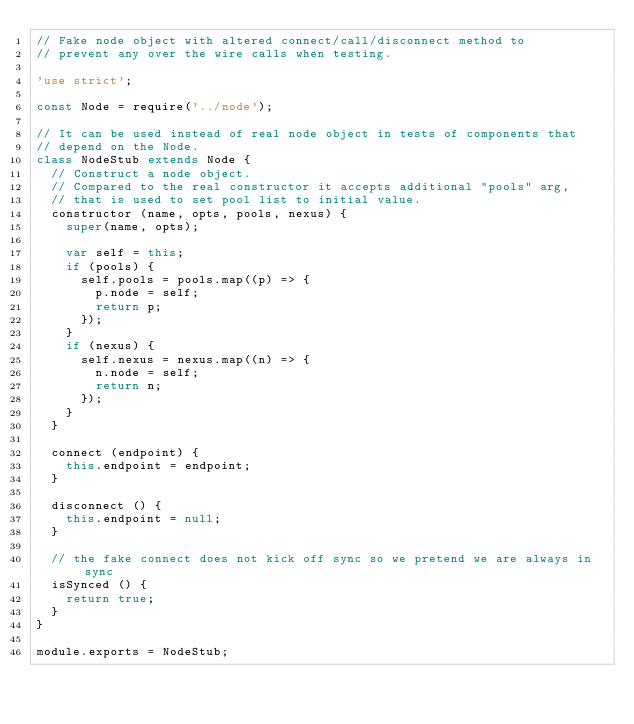Convert code to text. <code><loc_0><loc_0><loc_500><loc_500><_JavaScript_>// Fake node object with altered connect/call/disconnect method to
// prevent any over the wire calls when testing.

'use strict';

const Node = require('../node');

// It can be used instead of real node object in tests of components that
// depend on the Node.
class NodeStub extends Node {
  // Construct a node object.
  // Compared to the real constructor it accepts additional "pools" arg,
  // that is used to set pool list to initial value.
  constructor (name, opts, pools, nexus) {
    super(name, opts);

    var self = this;
    if (pools) {
      self.pools = pools.map((p) => {
        p.node = self;
        return p;
      });
    }
    if (nexus) {
      self.nexus = nexus.map((n) => {
        n.node = self;
        return n;
      });
    }
  }

  connect (endpoint) {
    this.endpoint = endpoint;
  }

  disconnect () {
    this.endpoint = null;
  }

  // the fake connect does not kick off sync so we pretend we are always in sync
  isSynced () {
    return true;
  }
}

module.exports = NodeStub;
</code> 